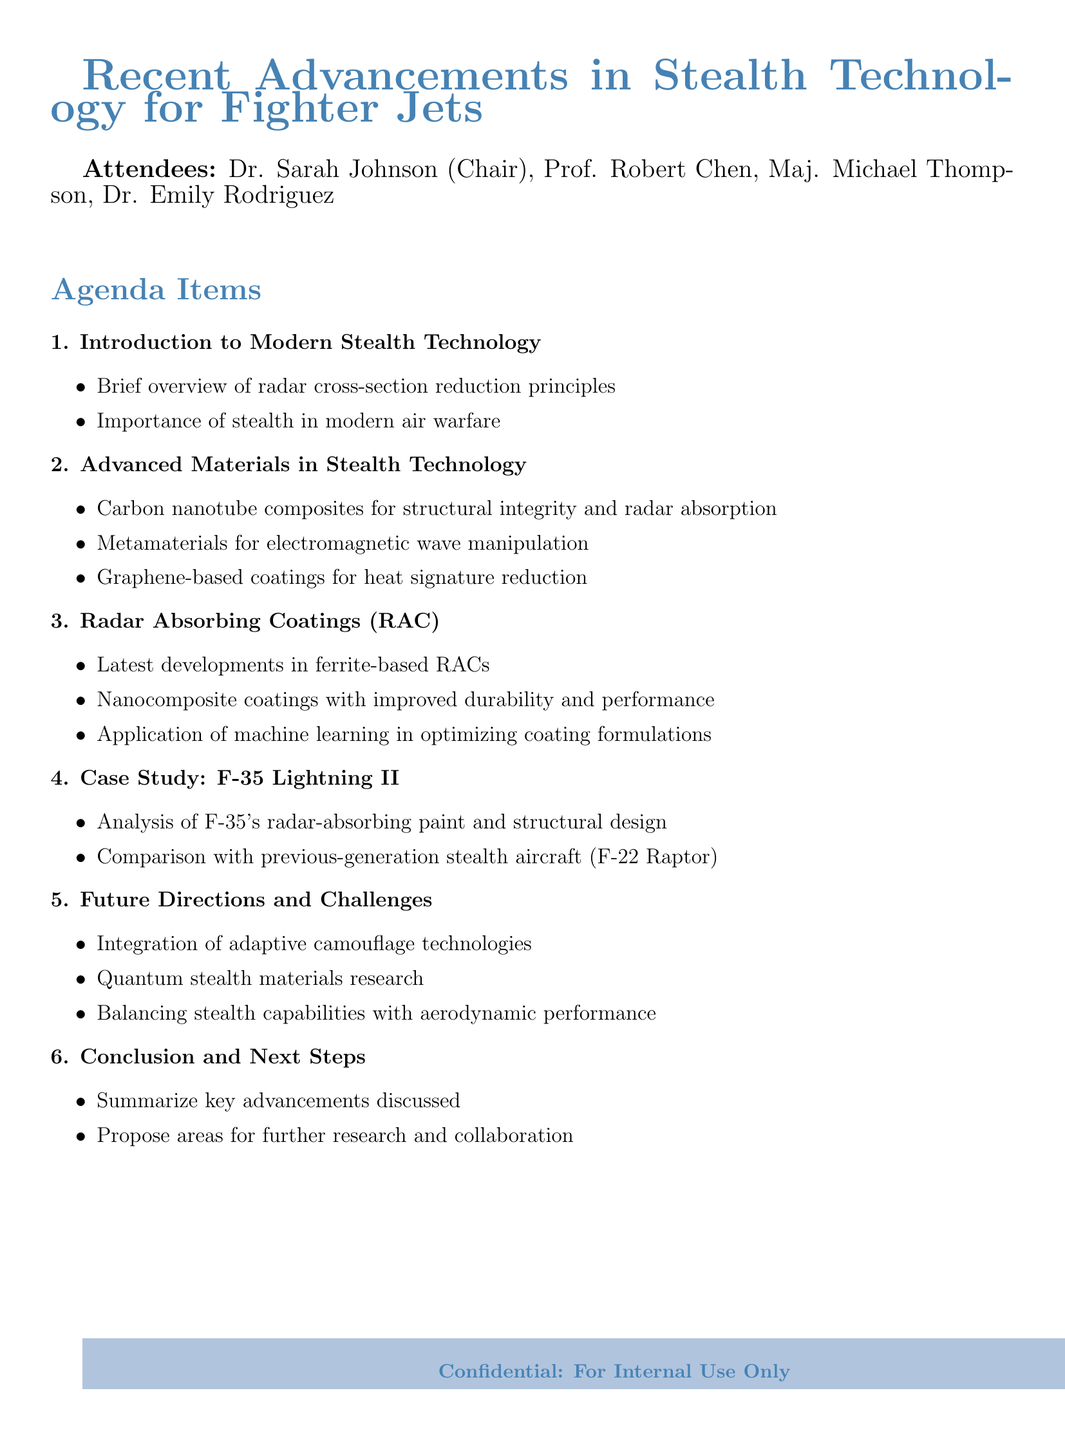What is the meeting date? The meeting date is listed at the beginning of the document.
Answer: 2023-05-15 Who chaired the meeting? The chair of the meeting is mentioned in the attendee list.
Answer: Dr. Sarah Johnson What is the first agenda topic? The first agenda topic is clearly specified in the agenda items section.
Answer: Introduction to Modern Stealth Technology Which advanced material is noted for structural integrity and radar absorption? This information is found in the section on Advanced Materials in Stealth Technology.
Answer: Carbon nanotube composites What are the latest developments in Radar Absorbing Coatings? The document lists key points regarding this topic under the corresponding agenda item.
Answer: Ferrite-based RACs How many attendees were present at the meeting? The number of attendees can be counted from the list included in the document.
Answer: 4 What is the case study discussed in the meeting? The case study is explicitly named in the agenda item regarding it.
Answer: F-35 Lightning II What is one of the future directions mentioned in the meeting? Future directions are listed in the corresponding agenda item discussing challenges.
Answer: Adaptive camouflage technologies 